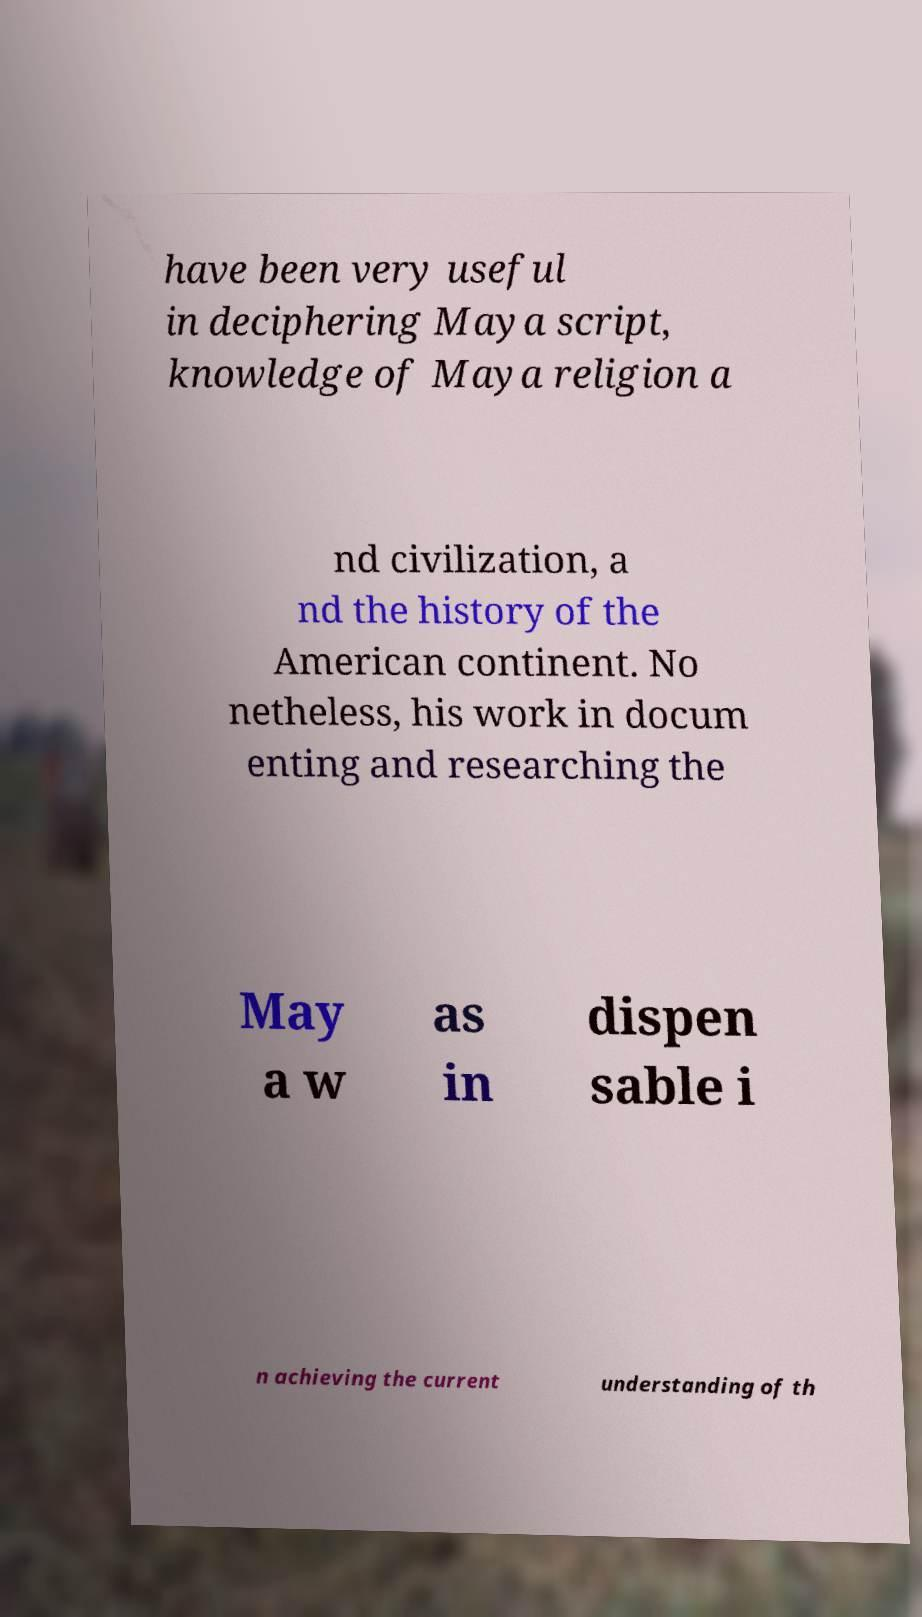Please identify and transcribe the text found in this image. have been very useful in deciphering Maya script, knowledge of Maya religion a nd civilization, a nd the history of the American continent. No netheless, his work in docum enting and researching the May a w as in dispen sable i n achieving the current understanding of th 